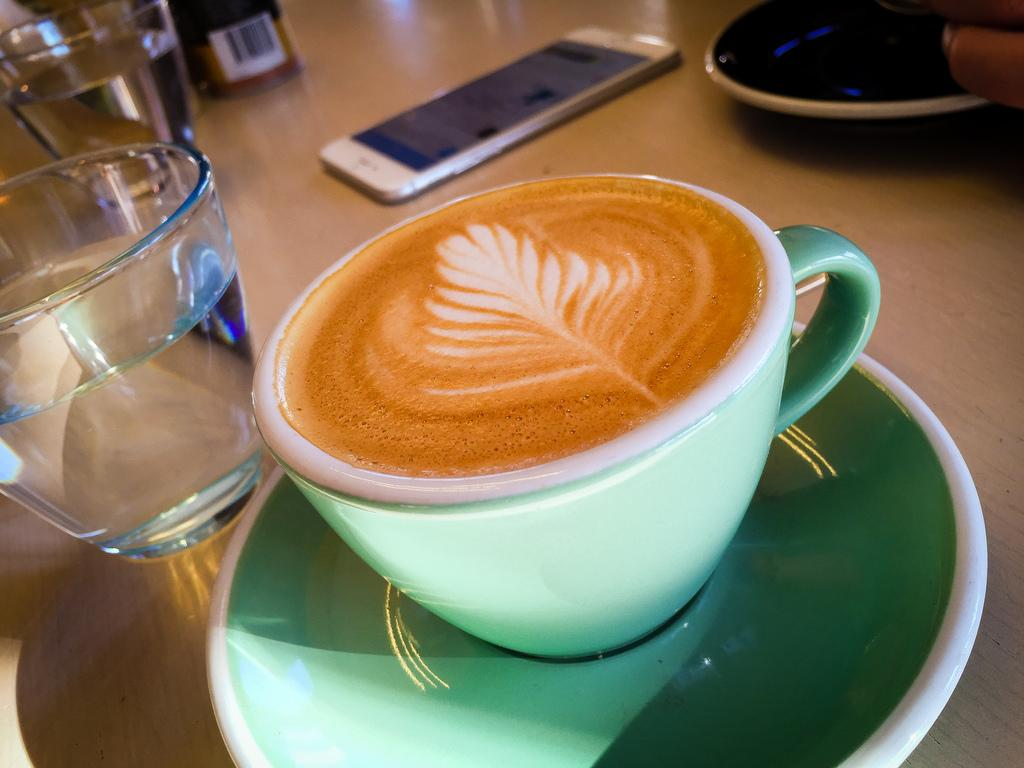What is in the cup that is on a saucer in the image? The cup contains cappuccino. What type of surface is the cup and saucer placed on? There is a wooden surface in the image. What else can be seen on the wooden surface? There are glasses with water, a mobile, a plate, and other items on the wooden surface. Is there any dust visible on the mobile in the image? There is no mention of dust in the provided facts, and therefore we cannot determine if dust is visible on the mobile in the image. 